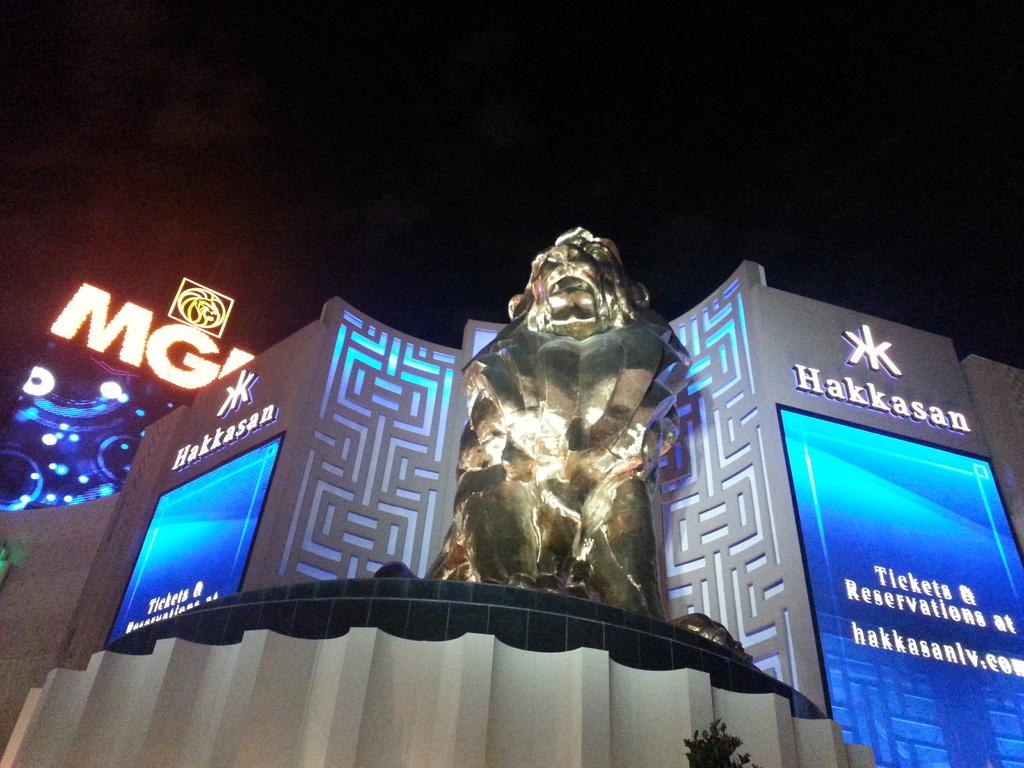<image>
Provide a brief description of the given image. The outside of a building called Hakkasan with a stature in front 